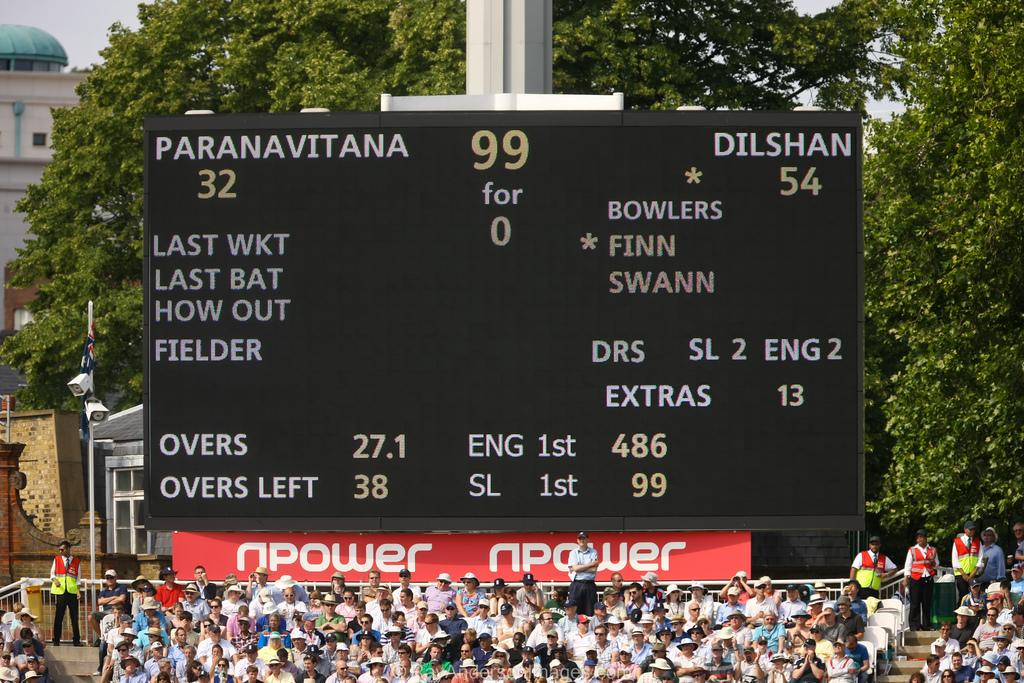Provide a one-sentence caption for the provided image. A scoreboard for the teams Paranavitana versing the Dilshan in a stadium with an audience of fans. 